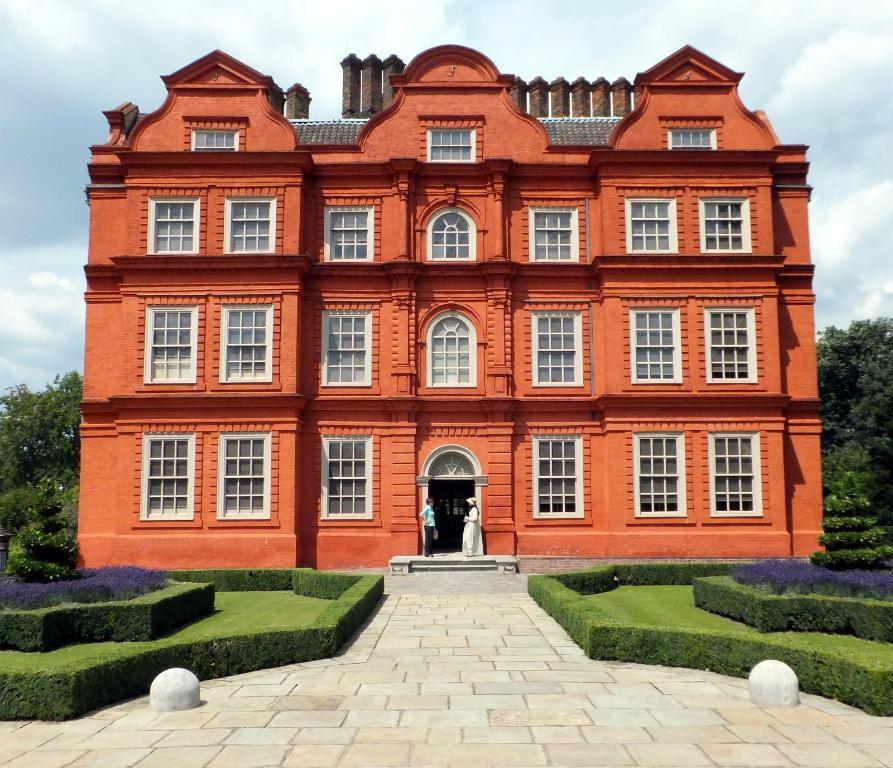Can you describe this image briefly? In the center of the image there is a building. There are two people standing on the stairs. In front of the building there are bushes, concrete structures. In the background of the image there are trees. At the top of the image there are clouds in the sky. 